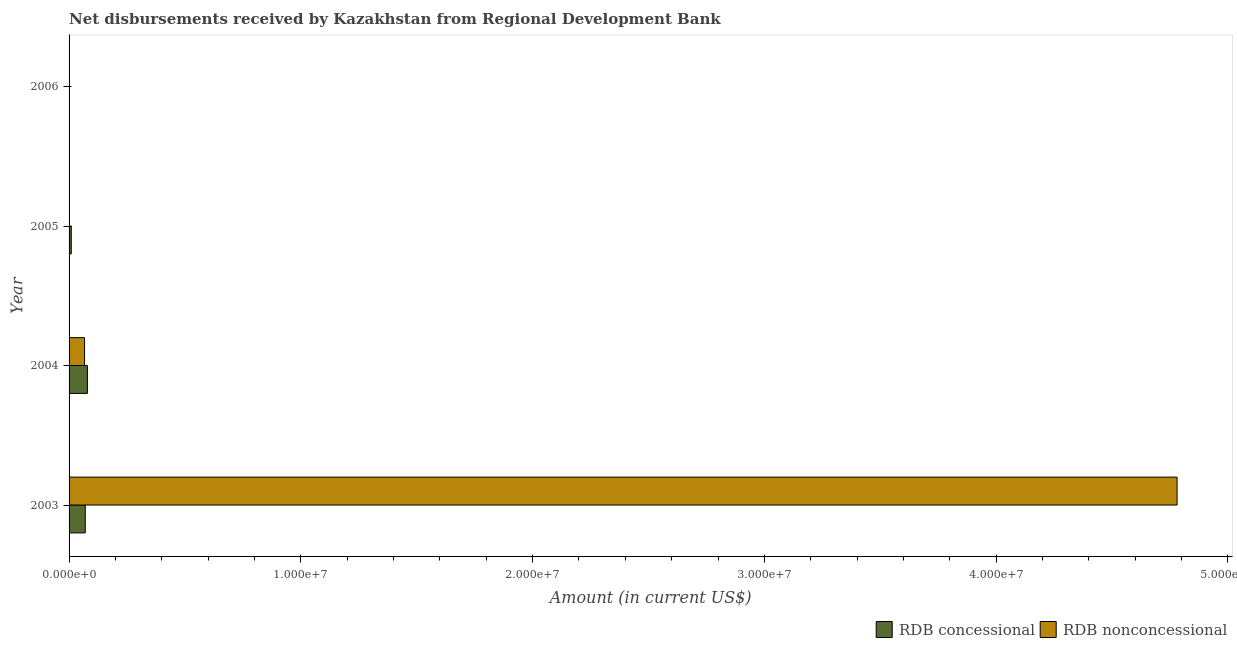How many different coloured bars are there?
Make the answer very short. 2. Are the number of bars on each tick of the Y-axis equal?
Give a very brief answer. No. How many bars are there on the 1st tick from the top?
Offer a terse response. 0. In how many cases, is the number of bars for a given year not equal to the number of legend labels?
Your answer should be compact. 2. What is the net concessional disbursements from rdb in 2003?
Your response must be concise. 6.98e+05. Across all years, what is the maximum net non concessional disbursements from rdb?
Provide a succinct answer. 4.78e+07. What is the total net non concessional disbursements from rdb in the graph?
Offer a very short reply. 4.85e+07. What is the difference between the net non concessional disbursements from rdb in 2003 and that in 2004?
Your answer should be very brief. 4.71e+07. What is the difference between the net non concessional disbursements from rdb in 2004 and the net concessional disbursements from rdb in 2006?
Your answer should be compact. 6.67e+05. What is the average net concessional disbursements from rdb per year?
Offer a very short reply. 3.96e+05. In the year 2004, what is the difference between the net concessional disbursements from rdb and net non concessional disbursements from rdb?
Your answer should be compact. 1.24e+05. In how many years, is the net concessional disbursements from rdb greater than 8000000 US$?
Your response must be concise. 0. What is the ratio of the net non concessional disbursements from rdb in 2003 to that in 2004?
Keep it short and to the point. 71.67. What is the difference between the highest and the second highest net concessional disbursements from rdb?
Make the answer very short. 9.30e+04. What is the difference between the highest and the lowest net concessional disbursements from rdb?
Provide a succinct answer. 7.91e+05. In how many years, is the net concessional disbursements from rdb greater than the average net concessional disbursements from rdb taken over all years?
Ensure brevity in your answer.  2. Is the sum of the net concessional disbursements from rdb in 2003 and 2004 greater than the maximum net non concessional disbursements from rdb across all years?
Provide a succinct answer. No. How many bars are there?
Provide a short and direct response. 5. Where does the legend appear in the graph?
Ensure brevity in your answer.  Bottom right. How are the legend labels stacked?
Your answer should be compact. Horizontal. What is the title of the graph?
Provide a succinct answer. Net disbursements received by Kazakhstan from Regional Development Bank. Does "Secondary Education" appear as one of the legend labels in the graph?
Your response must be concise. No. What is the Amount (in current US$) of RDB concessional in 2003?
Make the answer very short. 6.98e+05. What is the Amount (in current US$) of RDB nonconcessional in 2003?
Your answer should be compact. 4.78e+07. What is the Amount (in current US$) in RDB concessional in 2004?
Provide a succinct answer. 7.91e+05. What is the Amount (in current US$) in RDB nonconcessional in 2004?
Offer a very short reply. 6.67e+05. What is the Amount (in current US$) of RDB concessional in 2005?
Offer a terse response. 9.50e+04. Across all years, what is the maximum Amount (in current US$) in RDB concessional?
Offer a terse response. 7.91e+05. Across all years, what is the maximum Amount (in current US$) in RDB nonconcessional?
Provide a short and direct response. 4.78e+07. Across all years, what is the minimum Amount (in current US$) in RDB concessional?
Provide a short and direct response. 0. Across all years, what is the minimum Amount (in current US$) in RDB nonconcessional?
Make the answer very short. 0. What is the total Amount (in current US$) of RDB concessional in the graph?
Keep it short and to the point. 1.58e+06. What is the total Amount (in current US$) of RDB nonconcessional in the graph?
Ensure brevity in your answer.  4.85e+07. What is the difference between the Amount (in current US$) of RDB concessional in 2003 and that in 2004?
Your response must be concise. -9.30e+04. What is the difference between the Amount (in current US$) in RDB nonconcessional in 2003 and that in 2004?
Make the answer very short. 4.71e+07. What is the difference between the Amount (in current US$) of RDB concessional in 2003 and that in 2005?
Offer a very short reply. 6.03e+05. What is the difference between the Amount (in current US$) in RDB concessional in 2004 and that in 2005?
Your answer should be very brief. 6.96e+05. What is the difference between the Amount (in current US$) in RDB concessional in 2003 and the Amount (in current US$) in RDB nonconcessional in 2004?
Provide a short and direct response. 3.10e+04. What is the average Amount (in current US$) in RDB concessional per year?
Your response must be concise. 3.96e+05. What is the average Amount (in current US$) of RDB nonconcessional per year?
Make the answer very short. 1.21e+07. In the year 2003, what is the difference between the Amount (in current US$) in RDB concessional and Amount (in current US$) in RDB nonconcessional?
Ensure brevity in your answer.  -4.71e+07. In the year 2004, what is the difference between the Amount (in current US$) of RDB concessional and Amount (in current US$) of RDB nonconcessional?
Offer a terse response. 1.24e+05. What is the ratio of the Amount (in current US$) in RDB concessional in 2003 to that in 2004?
Provide a short and direct response. 0.88. What is the ratio of the Amount (in current US$) in RDB nonconcessional in 2003 to that in 2004?
Keep it short and to the point. 71.67. What is the ratio of the Amount (in current US$) of RDB concessional in 2003 to that in 2005?
Ensure brevity in your answer.  7.35. What is the ratio of the Amount (in current US$) in RDB concessional in 2004 to that in 2005?
Offer a terse response. 8.33. What is the difference between the highest and the second highest Amount (in current US$) of RDB concessional?
Give a very brief answer. 9.30e+04. What is the difference between the highest and the lowest Amount (in current US$) of RDB concessional?
Keep it short and to the point. 7.91e+05. What is the difference between the highest and the lowest Amount (in current US$) of RDB nonconcessional?
Provide a short and direct response. 4.78e+07. 